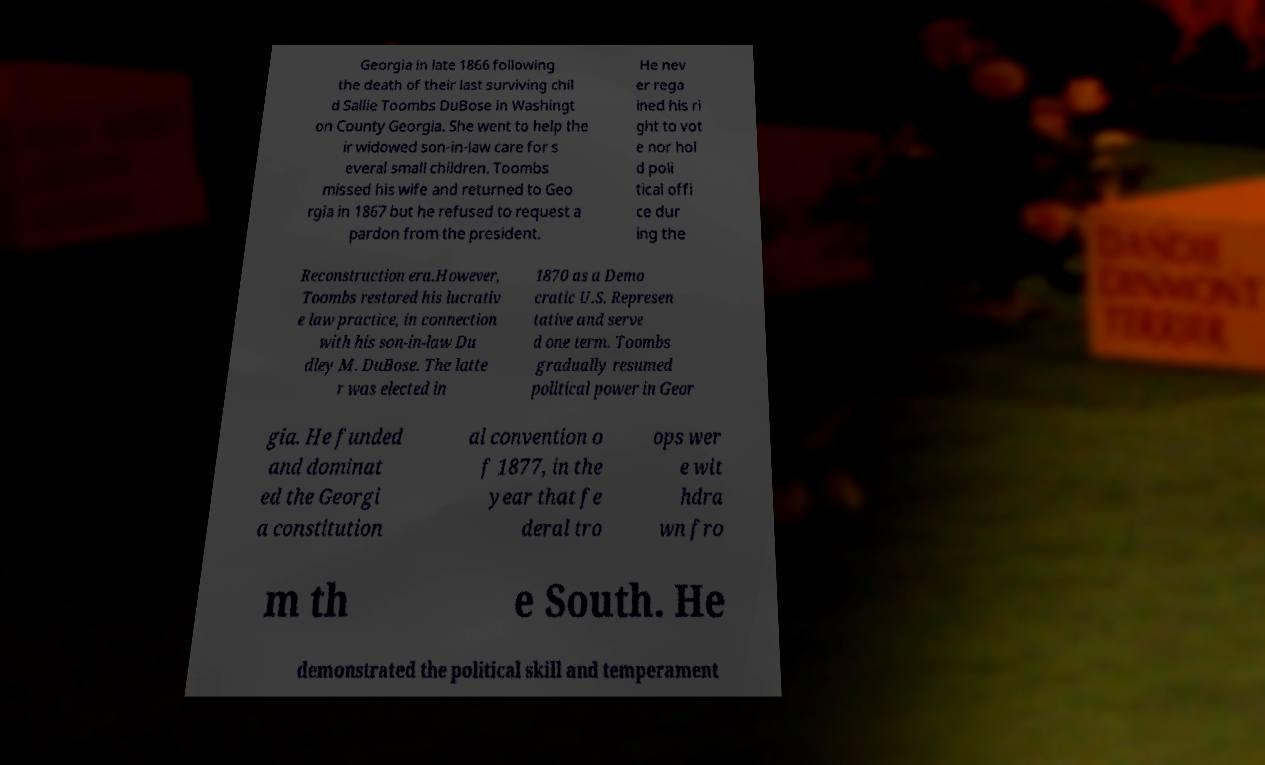I need the written content from this picture converted into text. Can you do that? Georgia in late 1866 following the death of their last surviving chil d Sallie Toombs DuBose in Washingt on County Georgia. She went to help the ir widowed son-in-law care for s everal small children. Toombs missed his wife and returned to Geo rgia in 1867 but he refused to request a pardon from the president. He nev er rega ined his ri ght to vot e nor hol d poli tical offi ce dur ing the Reconstruction era.However, Toombs restored his lucrativ e law practice, in connection with his son-in-law Du dley M. DuBose. The latte r was elected in 1870 as a Demo cratic U.S. Represen tative and serve d one term. Toombs gradually resumed political power in Geor gia. He funded and dominat ed the Georgi a constitution al convention o f 1877, in the year that fe deral tro ops wer e wit hdra wn fro m th e South. He demonstrated the political skill and temperament 